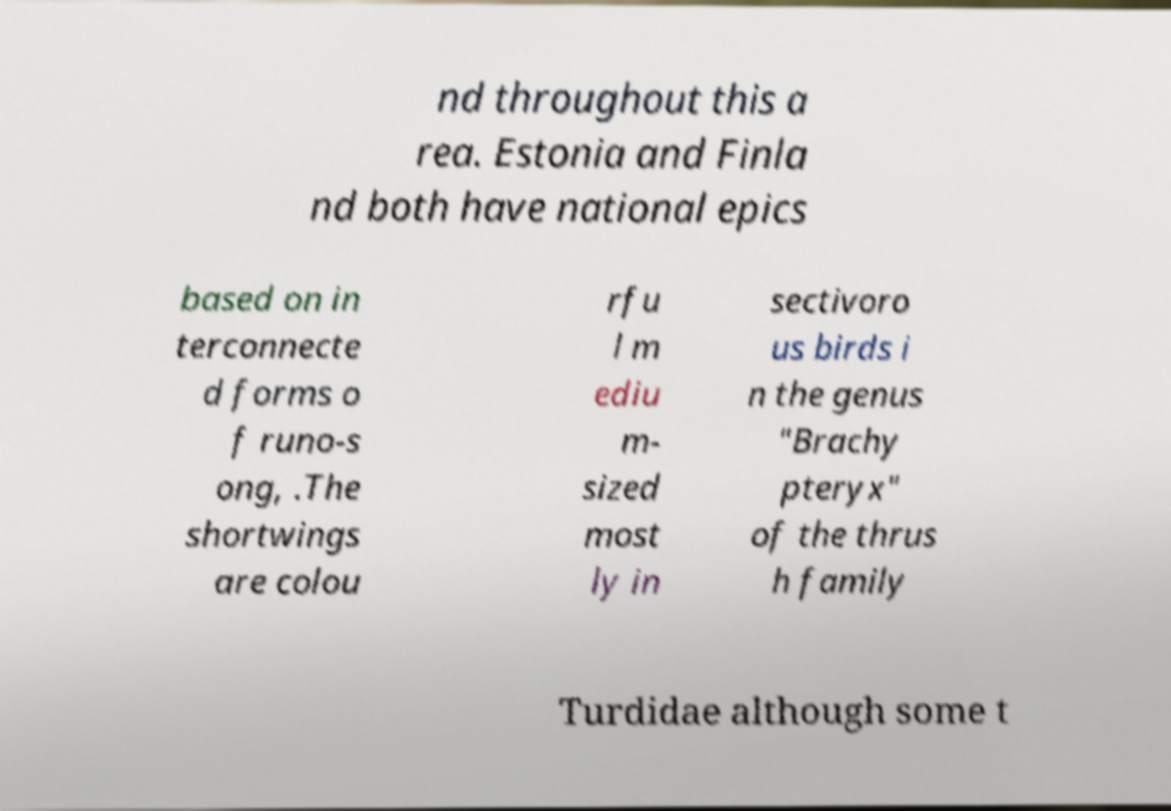Please identify and transcribe the text found in this image. nd throughout this a rea. Estonia and Finla nd both have national epics based on in terconnecte d forms o f runo-s ong, .The shortwings are colou rfu l m ediu m- sized most ly in sectivoro us birds i n the genus "Brachy pteryx" of the thrus h family Turdidae although some t 